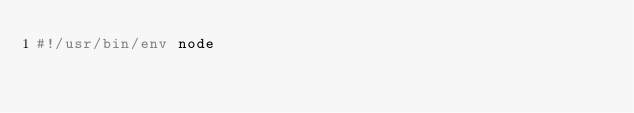<code> <loc_0><loc_0><loc_500><loc_500><_JavaScript_>#!/usr/bin/env node</code> 